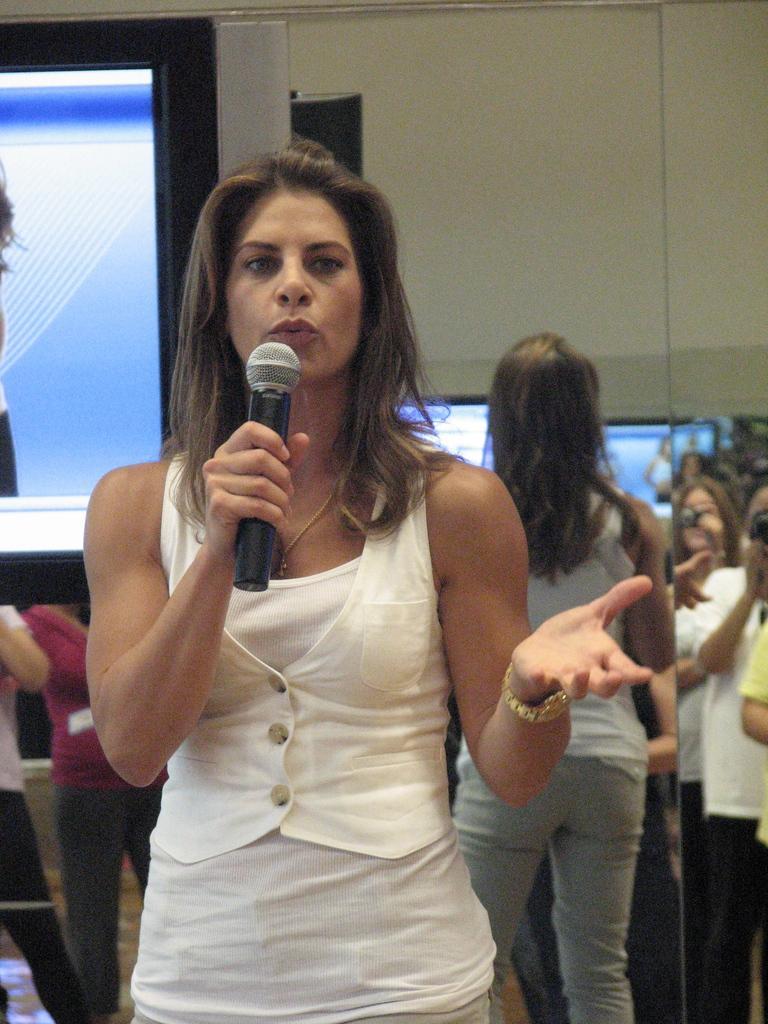How would you summarize this image in a sentence or two? a person is speaking holding a microphone in her hand. behind her there are other people standing. at the left corner there is a t. v 